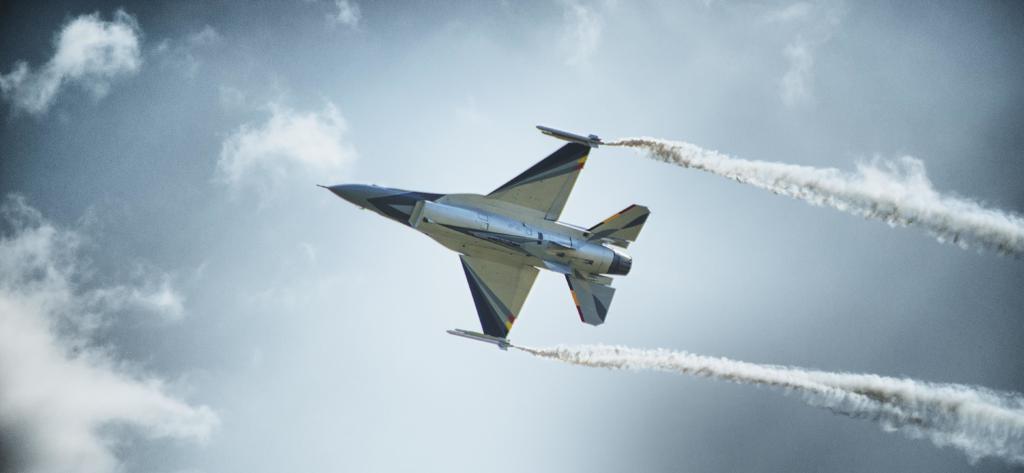How would you summarize this image in a sentence or two? In this image I can see an aircraft in the air and on the right side I can see smoke. I can also see clouds and the sky in the background. 